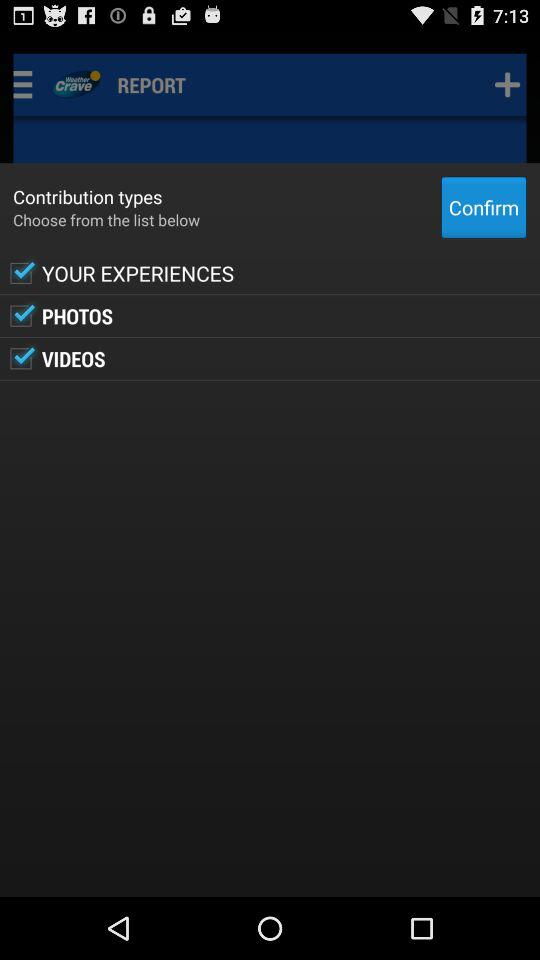What options are there to select in "Contribution types"? The options to select in "Contribution types" are "YOUR EXPERIENCES", "PHOTOS" and "VIDEOS". 